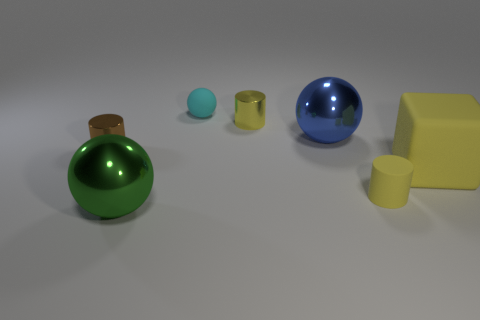Subtract all shiny balls. How many balls are left? 1 Subtract all yellow cylinders. How many cylinders are left? 1 Add 2 shiny balls. How many objects exist? 9 Subtract 1 cubes. How many cubes are left? 0 Add 7 small brown cylinders. How many small brown cylinders exist? 8 Subtract 0 blue blocks. How many objects are left? 7 Subtract all cubes. How many objects are left? 6 Subtract all purple balls. Subtract all purple cubes. How many balls are left? 3 Subtract all cyan spheres. How many blue cubes are left? 0 Subtract all tiny green blocks. Subtract all big green objects. How many objects are left? 6 